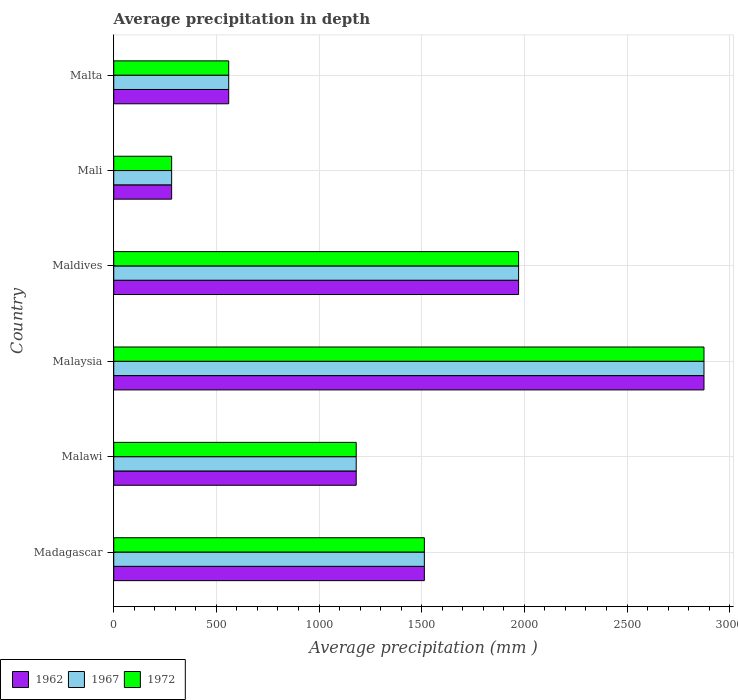How many different coloured bars are there?
Your answer should be very brief. 3. How many groups of bars are there?
Your response must be concise. 6. What is the label of the 4th group of bars from the top?
Give a very brief answer. Malaysia. What is the average precipitation in 1962 in Madagascar?
Your answer should be very brief. 1513. Across all countries, what is the maximum average precipitation in 1967?
Your answer should be compact. 2875. Across all countries, what is the minimum average precipitation in 1967?
Your response must be concise. 282. In which country was the average precipitation in 1967 maximum?
Offer a terse response. Malaysia. In which country was the average precipitation in 1962 minimum?
Keep it short and to the point. Mali. What is the total average precipitation in 1962 in the graph?
Your answer should be very brief. 8383. What is the difference between the average precipitation in 1972 in Malaysia and that in Mali?
Give a very brief answer. 2593. What is the difference between the average precipitation in 1972 in Malawi and the average precipitation in 1962 in Maldives?
Make the answer very short. -791. What is the average average precipitation in 1962 per country?
Your answer should be very brief. 1397.17. What is the difference between the average precipitation in 1972 and average precipitation in 1967 in Mali?
Give a very brief answer. 0. What is the ratio of the average precipitation in 1967 in Maldives to that in Mali?
Offer a terse response. 6.99. What is the difference between the highest and the second highest average precipitation in 1972?
Provide a succinct answer. 903. What is the difference between the highest and the lowest average precipitation in 1962?
Ensure brevity in your answer.  2593. What does the 2nd bar from the top in Maldives represents?
Your answer should be very brief. 1967. What does the 1st bar from the bottom in Mali represents?
Provide a short and direct response. 1962. Is it the case that in every country, the sum of the average precipitation in 1962 and average precipitation in 1967 is greater than the average precipitation in 1972?
Make the answer very short. Yes. Are all the bars in the graph horizontal?
Your answer should be very brief. Yes. What is the difference between two consecutive major ticks on the X-axis?
Make the answer very short. 500. Where does the legend appear in the graph?
Provide a succinct answer. Bottom left. How are the legend labels stacked?
Provide a succinct answer. Horizontal. What is the title of the graph?
Offer a terse response. Average precipitation in depth. Does "2010" appear as one of the legend labels in the graph?
Offer a very short reply. No. What is the label or title of the X-axis?
Make the answer very short. Average precipitation (mm ). What is the Average precipitation (mm ) in 1962 in Madagascar?
Provide a succinct answer. 1513. What is the Average precipitation (mm ) of 1967 in Madagascar?
Keep it short and to the point. 1513. What is the Average precipitation (mm ) in 1972 in Madagascar?
Your answer should be very brief. 1513. What is the Average precipitation (mm ) of 1962 in Malawi?
Provide a short and direct response. 1181. What is the Average precipitation (mm ) of 1967 in Malawi?
Make the answer very short. 1181. What is the Average precipitation (mm ) in 1972 in Malawi?
Give a very brief answer. 1181. What is the Average precipitation (mm ) in 1962 in Malaysia?
Keep it short and to the point. 2875. What is the Average precipitation (mm ) in 1967 in Malaysia?
Your answer should be very brief. 2875. What is the Average precipitation (mm ) in 1972 in Malaysia?
Your answer should be compact. 2875. What is the Average precipitation (mm ) of 1962 in Maldives?
Your answer should be very brief. 1972. What is the Average precipitation (mm ) in 1967 in Maldives?
Offer a terse response. 1972. What is the Average precipitation (mm ) of 1972 in Maldives?
Your response must be concise. 1972. What is the Average precipitation (mm ) of 1962 in Mali?
Your answer should be compact. 282. What is the Average precipitation (mm ) in 1967 in Mali?
Provide a short and direct response. 282. What is the Average precipitation (mm ) in 1972 in Mali?
Give a very brief answer. 282. What is the Average precipitation (mm ) of 1962 in Malta?
Ensure brevity in your answer.  560. What is the Average precipitation (mm ) of 1967 in Malta?
Make the answer very short. 560. What is the Average precipitation (mm ) in 1972 in Malta?
Offer a terse response. 560. Across all countries, what is the maximum Average precipitation (mm ) of 1962?
Offer a terse response. 2875. Across all countries, what is the maximum Average precipitation (mm ) of 1967?
Ensure brevity in your answer.  2875. Across all countries, what is the maximum Average precipitation (mm ) in 1972?
Ensure brevity in your answer.  2875. Across all countries, what is the minimum Average precipitation (mm ) in 1962?
Give a very brief answer. 282. Across all countries, what is the minimum Average precipitation (mm ) in 1967?
Offer a terse response. 282. Across all countries, what is the minimum Average precipitation (mm ) in 1972?
Give a very brief answer. 282. What is the total Average precipitation (mm ) in 1962 in the graph?
Ensure brevity in your answer.  8383. What is the total Average precipitation (mm ) in 1967 in the graph?
Give a very brief answer. 8383. What is the total Average precipitation (mm ) in 1972 in the graph?
Offer a terse response. 8383. What is the difference between the Average precipitation (mm ) of 1962 in Madagascar and that in Malawi?
Offer a terse response. 332. What is the difference between the Average precipitation (mm ) of 1967 in Madagascar and that in Malawi?
Keep it short and to the point. 332. What is the difference between the Average precipitation (mm ) of 1972 in Madagascar and that in Malawi?
Offer a terse response. 332. What is the difference between the Average precipitation (mm ) of 1962 in Madagascar and that in Malaysia?
Make the answer very short. -1362. What is the difference between the Average precipitation (mm ) in 1967 in Madagascar and that in Malaysia?
Your response must be concise. -1362. What is the difference between the Average precipitation (mm ) in 1972 in Madagascar and that in Malaysia?
Offer a very short reply. -1362. What is the difference between the Average precipitation (mm ) in 1962 in Madagascar and that in Maldives?
Your response must be concise. -459. What is the difference between the Average precipitation (mm ) in 1967 in Madagascar and that in Maldives?
Your answer should be compact. -459. What is the difference between the Average precipitation (mm ) of 1972 in Madagascar and that in Maldives?
Your response must be concise. -459. What is the difference between the Average precipitation (mm ) in 1962 in Madagascar and that in Mali?
Your answer should be very brief. 1231. What is the difference between the Average precipitation (mm ) of 1967 in Madagascar and that in Mali?
Provide a short and direct response. 1231. What is the difference between the Average precipitation (mm ) of 1972 in Madagascar and that in Mali?
Provide a succinct answer. 1231. What is the difference between the Average precipitation (mm ) of 1962 in Madagascar and that in Malta?
Offer a very short reply. 953. What is the difference between the Average precipitation (mm ) of 1967 in Madagascar and that in Malta?
Keep it short and to the point. 953. What is the difference between the Average precipitation (mm ) in 1972 in Madagascar and that in Malta?
Give a very brief answer. 953. What is the difference between the Average precipitation (mm ) in 1962 in Malawi and that in Malaysia?
Ensure brevity in your answer.  -1694. What is the difference between the Average precipitation (mm ) in 1967 in Malawi and that in Malaysia?
Your answer should be compact. -1694. What is the difference between the Average precipitation (mm ) in 1972 in Malawi and that in Malaysia?
Ensure brevity in your answer.  -1694. What is the difference between the Average precipitation (mm ) in 1962 in Malawi and that in Maldives?
Provide a succinct answer. -791. What is the difference between the Average precipitation (mm ) of 1967 in Malawi and that in Maldives?
Offer a very short reply. -791. What is the difference between the Average precipitation (mm ) in 1972 in Malawi and that in Maldives?
Provide a short and direct response. -791. What is the difference between the Average precipitation (mm ) of 1962 in Malawi and that in Mali?
Your answer should be compact. 899. What is the difference between the Average precipitation (mm ) in 1967 in Malawi and that in Mali?
Offer a terse response. 899. What is the difference between the Average precipitation (mm ) in 1972 in Malawi and that in Mali?
Make the answer very short. 899. What is the difference between the Average precipitation (mm ) in 1962 in Malawi and that in Malta?
Ensure brevity in your answer.  621. What is the difference between the Average precipitation (mm ) in 1967 in Malawi and that in Malta?
Your answer should be compact. 621. What is the difference between the Average precipitation (mm ) of 1972 in Malawi and that in Malta?
Make the answer very short. 621. What is the difference between the Average precipitation (mm ) in 1962 in Malaysia and that in Maldives?
Your response must be concise. 903. What is the difference between the Average precipitation (mm ) in 1967 in Malaysia and that in Maldives?
Make the answer very short. 903. What is the difference between the Average precipitation (mm ) in 1972 in Malaysia and that in Maldives?
Give a very brief answer. 903. What is the difference between the Average precipitation (mm ) of 1962 in Malaysia and that in Mali?
Keep it short and to the point. 2593. What is the difference between the Average precipitation (mm ) in 1967 in Malaysia and that in Mali?
Ensure brevity in your answer.  2593. What is the difference between the Average precipitation (mm ) in 1972 in Malaysia and that in Mali?
Provide a succinct answer. 2593. What is the difference between the Average precipitation (mm ) in 1962 in Malaysia and that in Malta?
Offer a terse response. 2315. What is the difference between the Average precipitation (mm ) in 1967 in Malaysia and that in Malta?
Make the answer very short. 2315. What is the difference between the Average precipitation (mm ) of 1972 in Malaysia and that in Malta?
Provide a short and direct response. 2315. What is the difference between the Average precipitation (mm ) in 1962 in Maldives and that in Mali?
Your answer should be very brief. 1690. What is the difference between the Average precipitation (mm ) of 1967 in Maldives and that in Mali?
Your answer should be very brief. 1690. What is the difference between the Average precipitation (mm ) of 1972 in Maldives and that in Mali?
Your answer should be compact. 1690. What is the difference between the Average precipitation (mm ) in 1962 in Maldives and that in Malta?
Offer a very short reply. 1412. What is the difference between the Average precipitation (mm ) of 1967 in Maldives and that in Malta?
Make the answer very short. 1412. What is the difference between the Average precipitation (mm ) in 1972 in Maldives and that in Malta?
Provide a short and direct response. 1412. What is the difference between the Average precipitation (mm ) of 1962 in Mali and that in Malta?
Give a very brief answer. -278. What is the difference between the Average precipitation (mm ) in 1967 in Mali and that in Malta?
Keep it short and to the point. -278. What is the difference between the Average precipitation (mm ) in 1972 in Mali and that in Malta?
Offer a very short reply. -278. What is the difference between the Average precipitation (mm ) in 1962 in Madagascar and the Average precipitation (mm ) in 1967 in Malawi?
Give a very brief answer. 332. What is the difference between the Average precipitation (mm ) of 1962 in Madagascar and the Average precipitation (mm ) of 1972 in Malawi?
Provide a short and direct response. 332. What is the difference between the Average precipitation (mm ) in 1967 in Madagascar and the Average precipitation (mm ) in 1972 in Malawi?
Provide a short and direct response. 332. What is the difference between the Average precipitation (mm ) of 1962 in Madagascar and the Average precipitation (mm ) of 1967 in Malaysia?
Your answer should be compact. -1362. What is the difference between the Average precipitation (mm ) of 1962 in Madagascar and the Average precipitation (mm ) of 1972 in Malaysia?
Provide a short and direct response. -1362. What is the difference between the Average precipitation (mm ) in 1967 in Madagascar and the Average precipitation (mm ) in 1972 in Malaysia?
Your answer should be very brief. -1362. What is the difference between the Average precipitation (mm ) of 1962 in Madagascar and the Average precipitation (mm ) of 1967 in Maldives?
Give a very brief answer. -459. What is the difference between the Average precipitation (mm ) in 1962 in Madagascar and the Average precipitation (mm ) in 1972 in Maldives?
Make the answer very short. -459. What is the difference between the Average precipitation (mm ) of 1967 in Madagascar and the Average precipitation (mm ) of 1972 in Maldives?
Ensure brevity in your answer.  -459. What is the difference between the Average precipitation (mm ) in 1962 in Madagascar and the Average precipitation (mm ) in 1967 in Mali?
Ensure brevity in your answer.  1231. What is the difference between the Average precipitation (mm ) in 1962 in Madagascar and the Average precipitation (mm ) in 1972 in Mali?
Keep it short and to the point. 1231. What is the difference between the Average precipitation (mm ) of 1967 in Madagascar and the Average precipitation (mm ) of 1972 in Mali?
Offer a terse response. 1231. What is the difference between the Average precipitation (mm ) of 1962 in Madagascar and the Average precipitation (mm ) of 1967 in Malta?
Keep it short and to the point. 953. What is the difference between the Average precipitation (mm ) of 1962 in Madagascar and the Average precipitation (mm ) of 1972 in Malta?
Ensure brevity in your answer.  953. What is the difference between the Average precipitation (mm ) in 1967 in Madagascar and the Average precipitation (mm ) in 1972 in Malta?
Offer a very short reply. 953. What is the difference between the Average precipitation (mm ) in 1962 in Malawi and the Average precipitation (mm ) in 1967 in Malaysia?
Your answer should be very brief. -1694. What is the difference between the Average precipitation (mm ) of 1962 in Malawi and the Average precipitation (mm ) of 1972 in Malaysia?
Keep it short and to the point. -1694. What is the difference between the Average precipitation (mm ) of 1967 in Malawi and the Average precipitation (mm ) of 1972 in Malaysia?
Offer a very short reply. -1694. What is the difference between the Average precipitation (mm ) in 1962 in Malawi and the Average precipitation (mm ) in 1967 in Maldives?
Your response must be concise. -791. What is the difference between the Average precipitation (mm ) in 1962 in Malawi and the Average precipitation (mm ) in 1972 in Maldives?
Give a very brief answer. -791. What is the difference between the Average precipitation (mm ) in 1967 in Malawi and the Average precipitation (mm ) in 1972 in Maldives?
Make the answer very short. -791. What is the difference between the Average precipitation (mm ) of 1962 in Malawi and the Average precipitation (mm ) of 1967 in Mali?
Your answer should be compact. 899. What is the difference between the Average precipitation (mm ) in 1962 in Malawi and the Average precipitation (mm ) in 1972 in Mali?
Ensure brevity in your answer.  899. What is the difference between the Average precipitation (mm ) of 1967 in Malawi and the Average precipitation (mm ) of 1972 in Mali?
Offer a very short reply. 899. What is the difference between the Average precipitation (mm ) of 1962 in Malawi and the Average precipitation (mm ) of 1967 in Malta?
Offer a terse response. 621. What is the difference between the Average precipitation (mm ) in 1962 in Malawi and the Average precipitation (mm ) in 1972 in Malta?
Your answer should be very brief. 621. What is the difference between the Average precipitation (mm ) in 1967 in Malawi and the Average precipitation (mm ) in 1972 in Malta?
Provide a short and direct response. 621. What is the difference between the Average precipitation (mm ) of 1962 in Malaysia and the Average precipitation (mm ) of 1967 in Maldives?
Provide a succinct answer. 903. What is the difference between the Average precipitation (mm ) in 1962 in Malaysia and the Average precipitation (mm ) in 1972 in Maldives?
Provide a succinct answer. 903. What is the difference between the Average precipitation (mm ) in 1967 in Malaysia and the Average precipitation (mm ) in 1972 in Maldives?
Give a very brief answer. 903. What is the difference between the Average precipitation (mm ) in 1962 in Malaysia and the Average precipitation (mm ) in 1967 in Mali?
Ensure brevity in your answer.  2593. What is the difference between the Average precipitation (mm ) in 1962 in Malaysia and the Average precipitation (mm ) in 1972 in Mali?
Make the answer very short. 2593. What is the difference between the Average precipitation (mm ) of 1967 in Malaysia and the Average precipitation (mm ) of 1972 in Mali?
Provide a succinct answer. 2593. What is the difference between the Average precipitation (mm ) of 1962 in Malaysia and the Average precipitation (mm ) of 1967 in Malta?
Your answer should be compact. 2315. What is the difference between the Average precipitation (mm ) in 1962 in Malaysia and the Average precipitation (mm ) in 1972 in Malta?
Give a very brief answer. 2315. What is the difference between the Average precipitation (mm ) in 1967 in Malaysia and the Average precipitation (mm ) in 1972 in Malta?
Keep it short and to the point. 2315. What is the difference between the Average precipitation (mm ) in 1962 in Maldives and the Average precipitation (mm ) in 1967 in Mali?
Provide a succinct answer. 1690. What is the difference between the Average precipitation (mm ) of 1962 in Maldives and the Average precipitation (mm ) of 1972 in Mali?
Offer a very short reply. 1690. What is the difference between the Average precipitation (mm ) in 1967 in Maldives and the Average precipitation (mm ) in 1972 in Mali?
Give a very brief answer. 1690. What is the difference between the Average precipitation (mm ) of 1962 in Maldives and the Average precipitation (mm ) of 1967 in Malta?
Make the answer very short. 1412. What is the difference between the Average precipitation (mm ) of 1962 in Maldives and the Average precipitation (mm ) of 1972 in Malta?
Keep it short and to the point. 1412. What is the difference between the Average precipitation (mm ) in 1967 in Maldives and the Average precipitation (mm ) in 1972 in Malta?
Offer a very short reply. 1412. What is the difference between the Average precipitation (mm ) in 1962 in Mali and the Average precipitation (mm ) in 1967 in Malta?
Ensure brevity in your answer.  -278. What is the difference between the Average precipitation (mm ) of 1962 in Mali and the Average precipitation (mm ) of 1972 in Malta?
Your response must be concise. -278. What is the difference between the Average precipitation (mm ) of 1967 in Mali and the Average precipitation (mm ) of 1972 in Malta?
Your answer should be compact. -278. What is the average Average precipitation (mm ) in 1962 per country?
Offer a terse response. 1397.17. What is the average Average precipitation (mm ) in 1967 per country?
Your answer should be very brief. 1397.17. What is the average Average precipitation (mm ) in 1972 per country?
Offer a terse response. 1397.17. What is the difference between the Average precipitation (mm ) of 1962 and Average precipitation (mm ) of 1972 in Madagascar?
Ensure brevity in your answer.  0. What is the difference between the Average precipitation (mm ) in 1962 and Average precipitation (mm ) in 1972 in Malawi?
Your answer should be very brief. 0. What is the difference between the Average precipitation (mm ) of 1962 and Average precipitation (mm ) of 1967 in Malaysia?
Your response must be concise. 0. What is the difference between the Average precipitation (mm ) of 1962 and Average precipitation (mm ) of 1967 in Mali?
Your answer should be very brief. 0. What is the difference between the Average precipitation (mm ) in 1967 and Average precipitation (mm ) in 1972 in Mali?
Provide a succinct answer. 0. What is the ratio of the Average precipitation (mm ) in 1962 in Madagascar to that in Malawi?
Offer a very short reply. 1.28. What is the ratio of the Average precipitation (mm ) of 1967 in Madagascar to that in Malawi?
Provide a succinct answer. 1.28. What is the ratio of the Average precipitation (mm ) in 1972 in Madagascar to that in Malawi?
Make the answer very short. 1.28. What is the ratio of the Average precipitation (mm ) of 1962 in Madagascar to that in Malaysia?
Offer a very short reply. 0.53. What is the ratio of the Average precipitation (mm ) of 1967 in Madagascar to that in Malaysia?
Keep it short and to the point. 0.53. What is the ratio of the Average precipitation (mm ) of 1972 in Madagascar to that in Malaysia?
Your answer should be very brief. 0.53. What is the ratio of the Average precipitation (mm ) in 1962 in Madagascar to that in Maldives?
Your answer should be compact. 0.77. What is the ratio of the Average precipitation (mm ) in 1967 in Madagascar to that in Maldives?
Offer a terse response. 0.77. What is the ratio of the Average precipitation (mm ) in 1972 in Madagascar to that in Maldives?
Provide a short and direct response. 0.77. What is the ratio of the Average precipitation (mm ) of 1962 in Madagascar to that in Mali?
Provide a succinct answer. 5.37. What is the ratio of the Average precipitation (mm ) in 1967 in Madagascar to that in Mali?
Provide a short and direct response. 5.37. What is the ratio of the Average precipitation (mm ) of 1972 in Madagascar to that in Mali?
Provide a succinct answer. 5.37. What is the ratio of the Average precipitation (mm ) in 1962 in Madagascar to that in Malta?
Offer a terse response. 2.7. What is the ratio of the Average precipitation (mm ) in 1967 in Madagascar to that in Malta?
Ensure brevity in your answer.  2.7. What is the ratio of the Average precipitation (mm ) of 1972 in Madagascar to that in Malta?
Give a very brief answer. 2.7. What is the ratio of the Average precipitation (mm ) of 1962 in Malawi to that in Malaysia?
Your response must be concise. 0.41. What is the ratio of the Average precipitation (mm ) in 1967 in Malawi to that in Malaysia?
Make the answer very short. 0.41. What is the ratio of the Average precipitation (mm ) of 1972 in Malawi to that in Malaysia?
Provide a short and direct response. 0.41. What is the ratio of the Average precipitation (mm ) of 1962 in Malawi to that in Maldives?
Provide a short and direct response. 0.6. What is the ratio of the Average precipitation (mm ) of 1967 in Malawi to that in Maldives?
Offer a terse response. 0.6. What is the ratio of the Average precipitation (mm ) in 1972 in Malawi to that in Maldives?
Provide a short and direct response. 0.6. What is the ratio of the Average precipitation (mm ) in 1962 in Malawi to that in Mali?
Give a very brief answer. 4.19. What is the ratio of the Average precipitation (mm ) of 1967 in Malawi to that in Mali?
Make the answer very short. 4.19. What is the ratio of the Average precipitation (mm ) in 1972 in Malawi to that in Mali?
Offer a terse response. 4.19. What is the ratio of the Average precipitation (mm ) in 1962 in Malawi to that in Malta?
Offer a terse response. 2.11. What is the ratio of the Average precipitation (mm ) in 1967 in Malawi to that in Malta?
Your answer should be very brief. 2.11. What is the ratio of the Average precipitation (mm ) of 1972 in Malawi to that in Malta?
Offer a terse response. 2.11. What is the ratio of the Average precipitation (mm ) in 1962 in Malaysia to that in Maldives?
Provide a succinct answer. 1.46. What is the ratio of the Average precipitation (mm ) of 1967 in Malaysia to that in Maldives?
Give a very brief answer. 1.46. What is the ratio of the Average precipitation (mm ) of 1972 in Malaysia to that in Maldives?
Your answer should be compact. 1.46. What is the ratio of the Average precipitation (mm ) in 1962 in Malaysia to that in Mali?
Provide a short and direct response. 10.2. What is the ratio of the Average precipitation (mm ) of 1967 in Malaysia to that in Mali?
Your answer should be very brief. 10.2. What is the ratio of the Average precipitation (mm ) of 1972 in Malaysia to that in Mali?
Ensure brevity in your answer.  10.2. What is the ratio of the Average precipitation (mm ) of 1962 in Malaysia to that in Malta?
Make the answer very short. 5.13. What is the ratio of the Average precipitation (mm ) in 1967 in Malaysia to that in Malta?
Ensure brevity in your answer.  5.13. What is the ratio of the Average precipitation (mm ) of 1972 in Malaysia to that in Malta?
Give a very brief answer. 5.13. What is the ratio of the Average precipitation (mm ) in 1962 in Maldives to that in Mali?
Offer a terse response. 6.99. What is the ratio of the Average precipitation (mm ) of 1967 in Maldives to that in Mali?
Provide a succinct answer. 6.99. What is the ratio of the Average precipitation (mm ) in 1972 in Maldives to that in Mali?
Provide a succinct answer. 6.99. What is the ratio of the Average precipitation (mm ) of 1962 in Maldives to that in Malta?
Offer a very short reply. 3.52. What is the ratio of the Average precipitation (mm ) of 1967 in Maldives to that in Malta?
Offer a terse response. 3.52. What is the ratio of the Average precipitation (mm ) in 1972 in Maldives to that in Malta?
Ensure brevity in your answer.  3.52. What is the ratio of the Average precipitation (mm ) of 1962 in Mali to that in Malta?
Your response must be concise. 0.5. What is the ratio of the Average precipitation (mm ) in 1967 in Mali to that in Malta?
Give a very brief answer. 0.5. What is the ratio of the Average precipitation (mm ) in 1972 in Mali to that in Malta?
Offer a terse response. 0.5. What is the difference between the highest and the second highest Average precipitation (mm ) of 1962?
Provide a succinct answer. 903. What is the difference between the highest and the second highest Average precipitation (mm ) of 1967?
Make the answer very short. 903. What is the difference between the highest and the second highest Average precipitation (mm ) in 1972?
Your answer should be very brief. 903. What is the difference between the highest and the lowest Average precipitation (mm ) in 1962?
Ensure brevity in your answer.  2593. What is the difference between the highest and the lowest Average precipitation (mm ) in 1967?
Give a very brief answer. 2593. What is the difference between the highest and the lowest Average precipitation (mm ) in 1972?
Provide a succinct answer. 2593. 